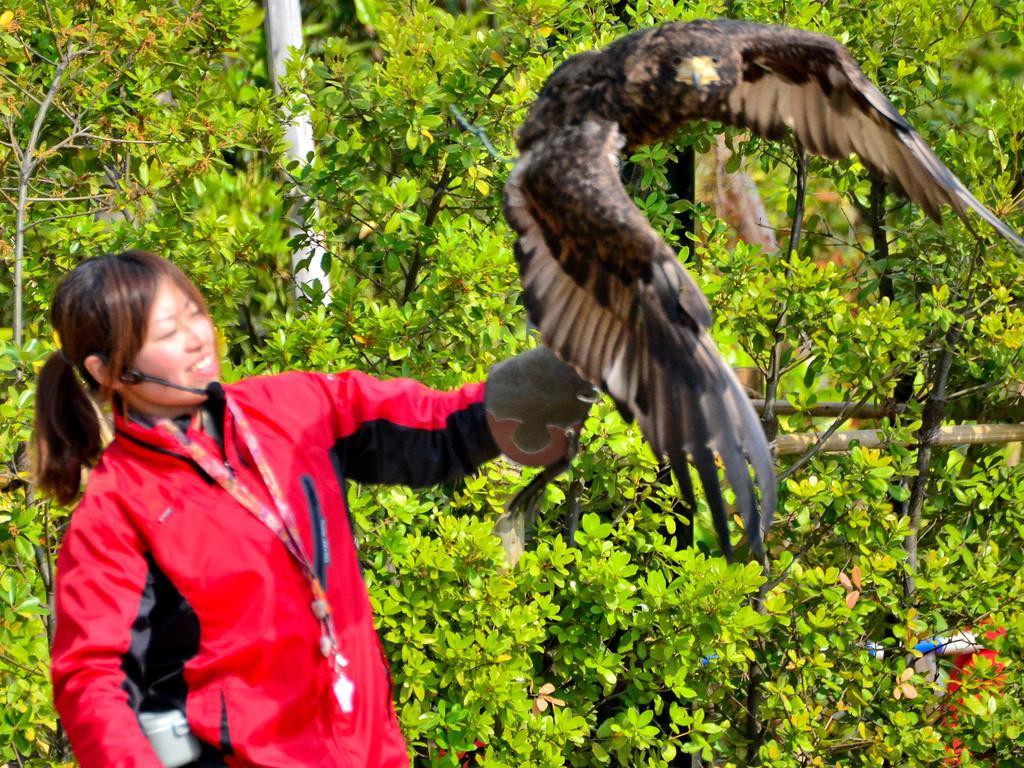How would you summarize this image in a sentence or two? In this image I can see a person standing holding a bird. The person is wearing red color jacket and the bird is in brown and cream color. Background I can see trees in green color. 